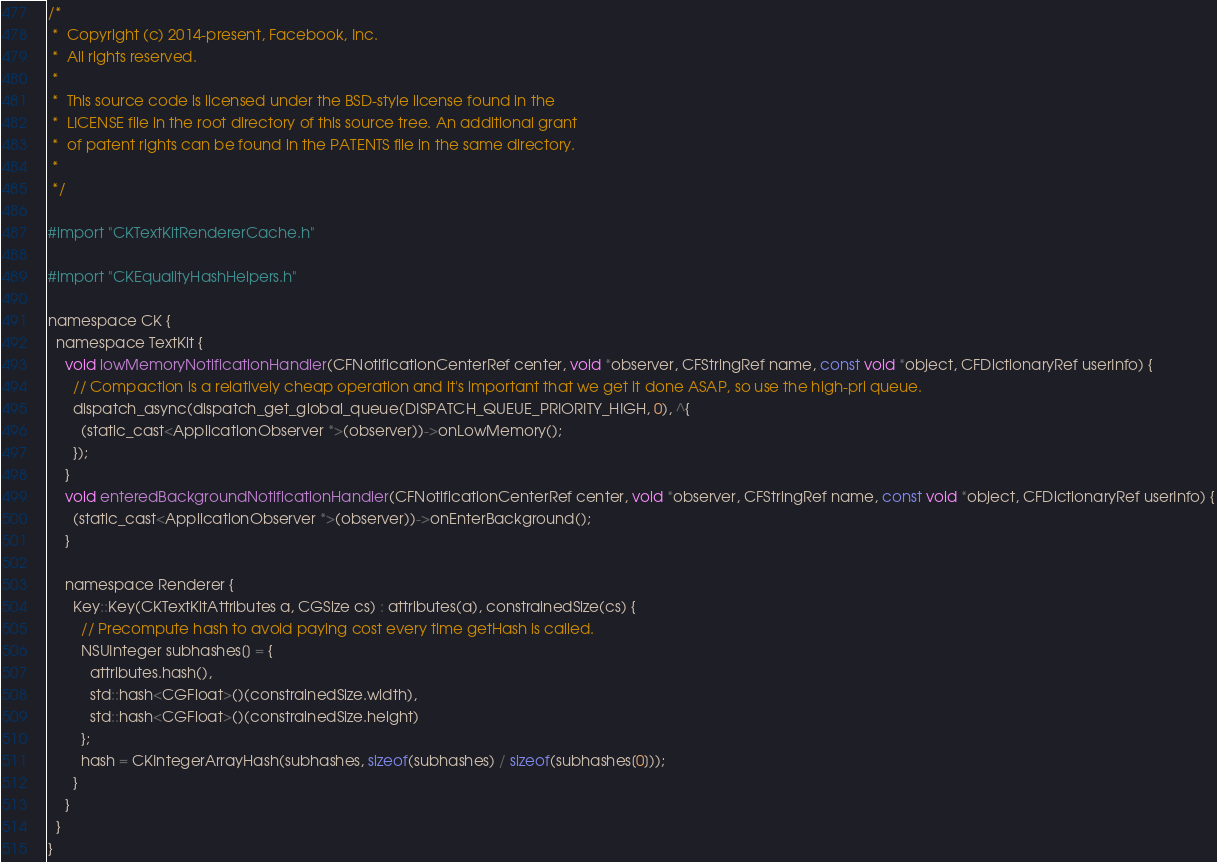Convert code to text. <code><loc_0><loc_0><loc_500><loc_500><_ObjectiveC_>/*
 *  Copyright (c) 2014-present, Facebook, Inc.
 *  All rights reserved.
 *
 *  This source code is licensed under the BSD-style license found in the
 *  LICENSE file in the root directory of this source tree. An additional grant
 *  of patent rights can be found in the PATENTS file in the same directory.
 *
 */

#import "CKTextKitRendererCache.h"

#import "CKEqualityHashHelpers.h"

namespace CK {
  namespace TextKit {
    void lowMemoryNotificationHandler(CFNotificationCenterRef center, void *observer, CFStringRef name, const void *object, CFDictionaryRef userInfo) {
      // Compaction is a relatively cheap operation and it's important that we get it done ASAP, so use the high-pri queue.
      dispatch_async(dispatch_get_global_queue(DISPATCH_QUEUE_PRIORITY_HIGH, 0), ^{
        (static_cast<ApplicationObserver *>(observer))->onLowMemory();
      });
    }
    void enteredBackgroundNotificationHandler(CFNotificationCenterRef center, void *observer, CFStringRef name, const void *object, CFDictionaryRef userInfo) {
      (static_cast<ApplicationObserver *>(observer))->onEnterBackground();
    }

    namespace Renderer {
      Key::Key(CKTextKitAttributes a, CGSize cs) : attributes(a), constrainedSize(cs) {
        // Precompute hash to avoid paying cost every time getHash is called.
        NSUInteger subhashes[] = {
          attributes.hash(),
          std::hash<CGFloat>()(constrainedSize.width),
          std::hash<CGFloat>()(constrainedSize.height)
        };
        hash = CKIntegerArrayHash(subhashes, sizeof(subhashes) / sizeof(subhashes[0]));
      }
    }
  }
}
</code> 